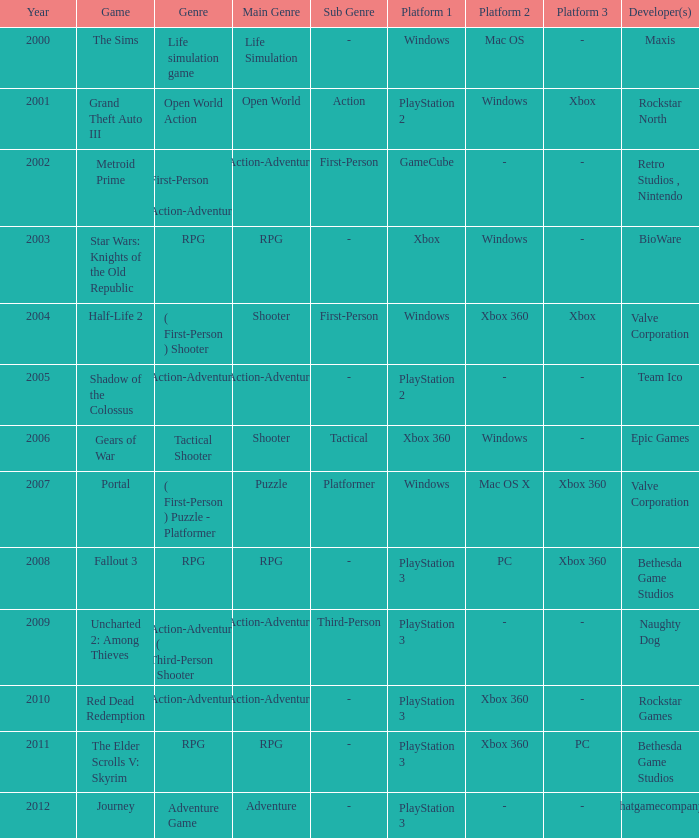What game was in 2011? The Elder Scrolls V: Skyrim. 